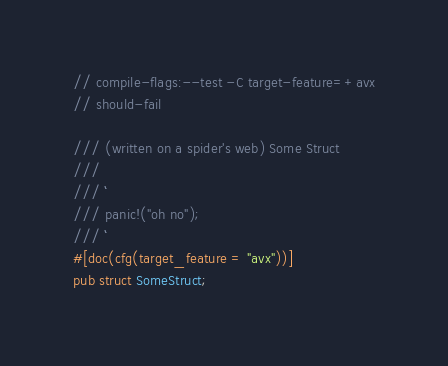<code> <loc_0><loc_0><loc_500><loc_500><_Rust_>// compile-flags:--test -C target-feature=+avx
// should-fail

/// (written on a spider's web) Some Struct
///
/// ```
/// panic!("oh no");
/// ```
#[doc(cfg(target_feature = "avx"))]
pub struct SomeStruct;
</code> 